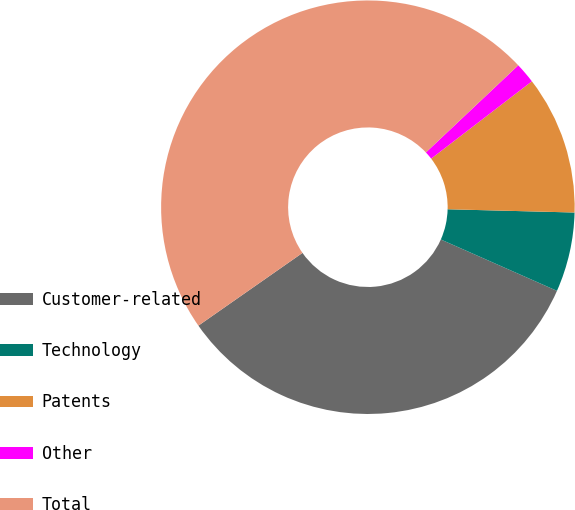Convert chart. <chart><loc_0><loc_0><loc_500><loc_500><pie_chart><fcel>Customer-related<fcel>Technology<fcel>Patents<fcel>Other<fcel>Total<nl><fcel>33.67%<fcel>6.22%<fcel>10.83%<fcel>1.62%<fcel>47.67%<nl></chart> 